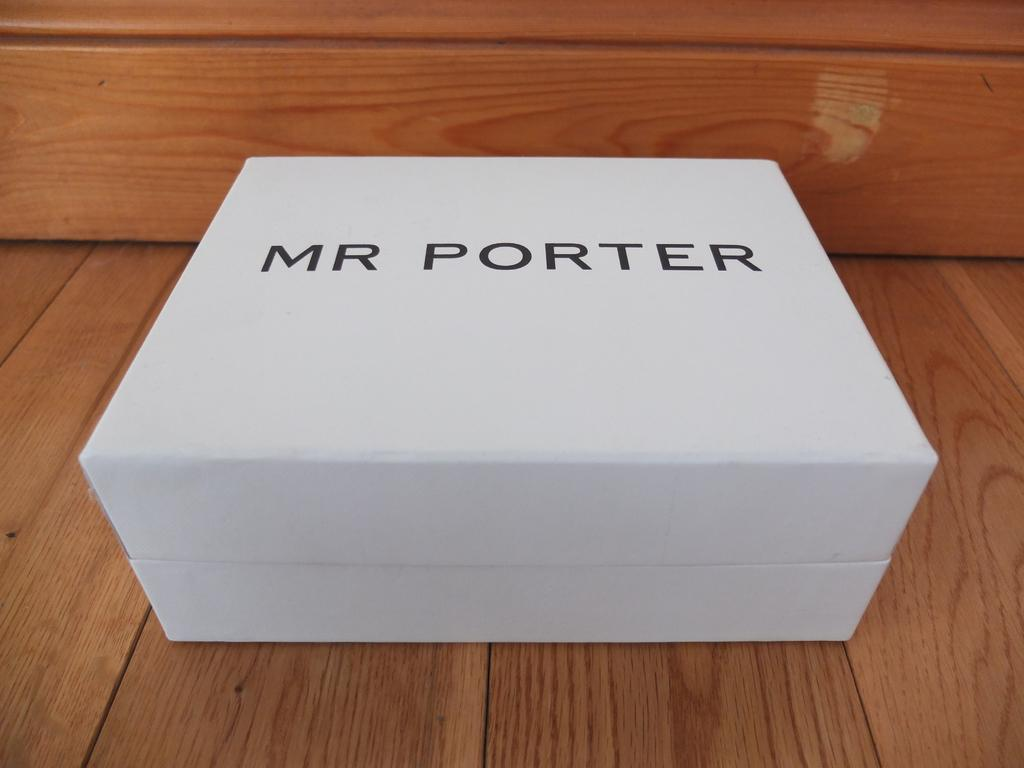<image>
Give a short and clear explanation of the subsequent image. A white box on a table that says Mr Porter. 